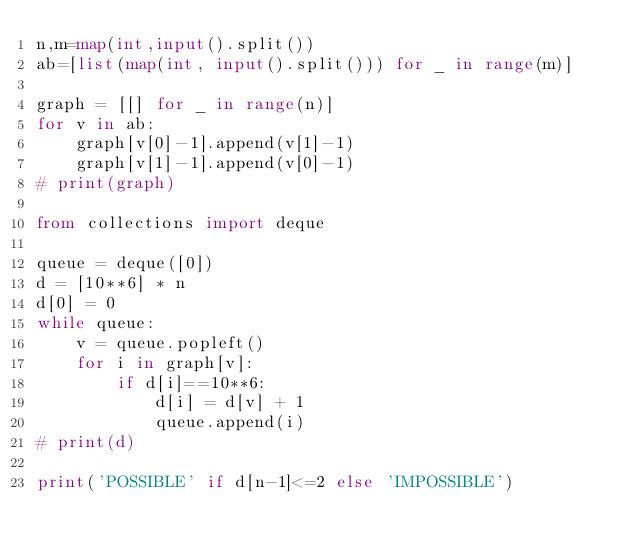<code> <loc_0><loc_0><loc_500><loc_500><_Python_>n,m=map(int,input().split())
ab=[list(map(int, input().split())) for _ in range(m)]

graph = [[] for _ in range(n)]
for v in ab:
    graph[v[0]-1].append(v[1]-1)
    graph[v[1]-1].append(v[0]-1)
# print(graph)

from collections import deque

queue = deque([0])
d = [10**6] * n
d[0] = 0
while queue:
    v = queue.popleft()
    for i in graph[v]:
        if d[i]==10**6:
            d[i] = d[v] + 1
            queue.append(i)
# print(d)

print('POSSIBLE' if d[n-1]<=2 else 'IMPOSSIBLE')

</code> 